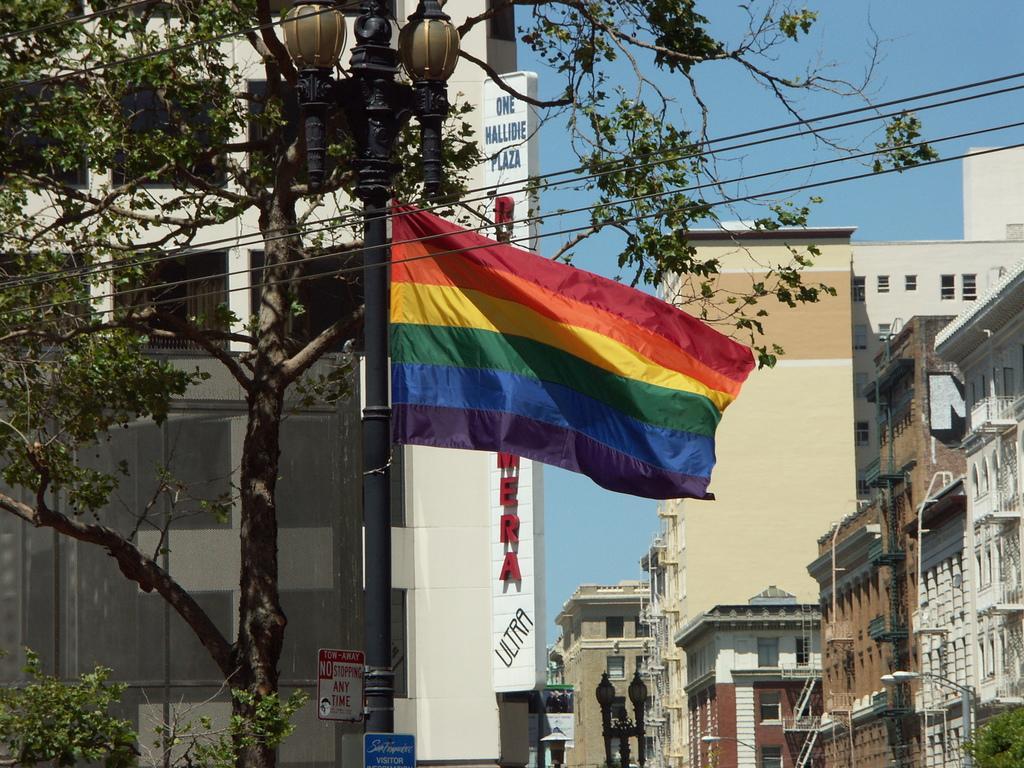Can you describe this image briefly? In the image we can see there are lot of buildings and there is a street light pole on which there is a multi colour flag. There is a tree. 